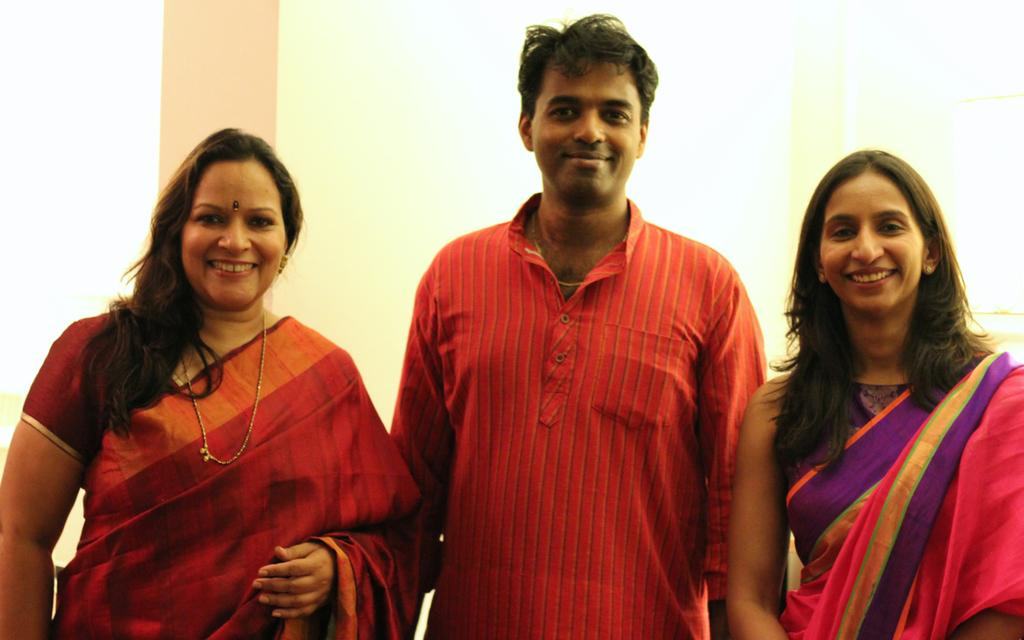How many people are present in the image? There are two ladies and one man in the image. Can you describe the positioning of the man in the image? The man is in the center of the image. What type of wood can be seen in the image? There is no wood present in the image. How many deer are visible in the image? There are no deer visible in the image. 